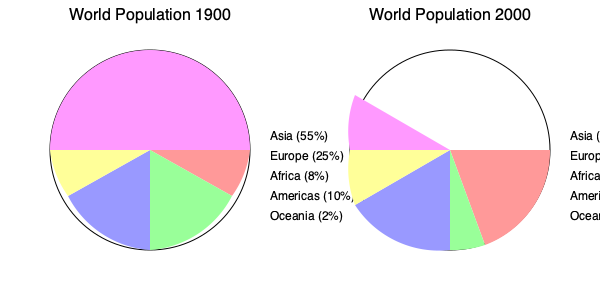Analyze the pie charts representing the distribution of world population by continent in 1900 and 2000. Which continent experienced the most significant percentage decrease in its share of the global population during this period, and what historical factors might explain this change? To answer this question, we need to follow these steps:

1. Compare the percentages for each continent between 1900 and 2000:
   - Asia: 55% to 61% (increase)
   - Europe: 25% to 12% (decrease)
   - Africa: 8% to 13% (increase)
   - Americas: 10% to 13% (slight increase)
   - Oceania: 2% to 1% (slight decrease)

2. Identify the continent with the largest percentage decrease:
   Europe shows the most significant decrease, from 25% to 12%, a 13 percentage point drop.

3. Consider historical factors that might explain this change:
   a) Two World Wars primarily fought in Europe, resulting in millions of casualties.
   b) The influenza pandemic of 1918-1919, which hit Europe particularly hard.
   c) Lower birth rates in European countries compared to developing nations in Asia and Africa.
   d) Increased life expectancy and population growth in developing countries due to improved healthcare and living conditions.
   e) Migration from Europe to other continents, particularly the Americas and Oceania.
   f) Decolonization and independence movements in Asia and Africa, leading to improved living conditions and population growth in these regions.

The combination of these factors led to a relative decline in Europe's share of the global population, while other continents, particularly Asia and Africa, saw significant increases in their population shares.
Answer: Europe; wars, pandemics, lower birth rates, and rapid population growth in developing countries. 